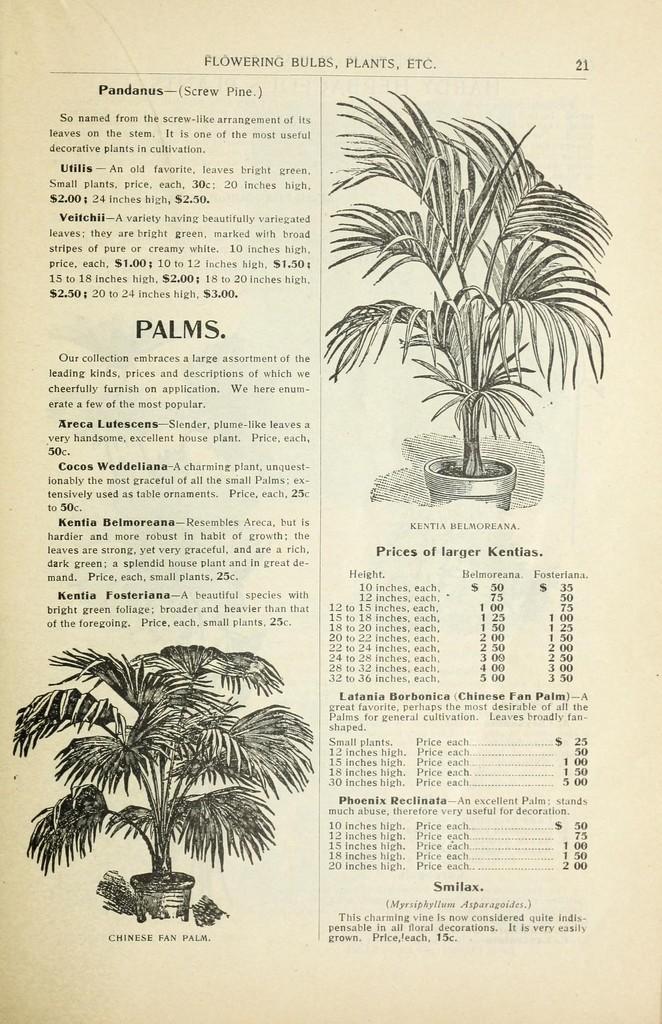In one or two sentences, can you explain what this image depicts? In this picture we can see a paper. At the top right corner a plant, pot are there. At the bottom left corner we can see a plant and pot are present. In the background of the image some text is there. 